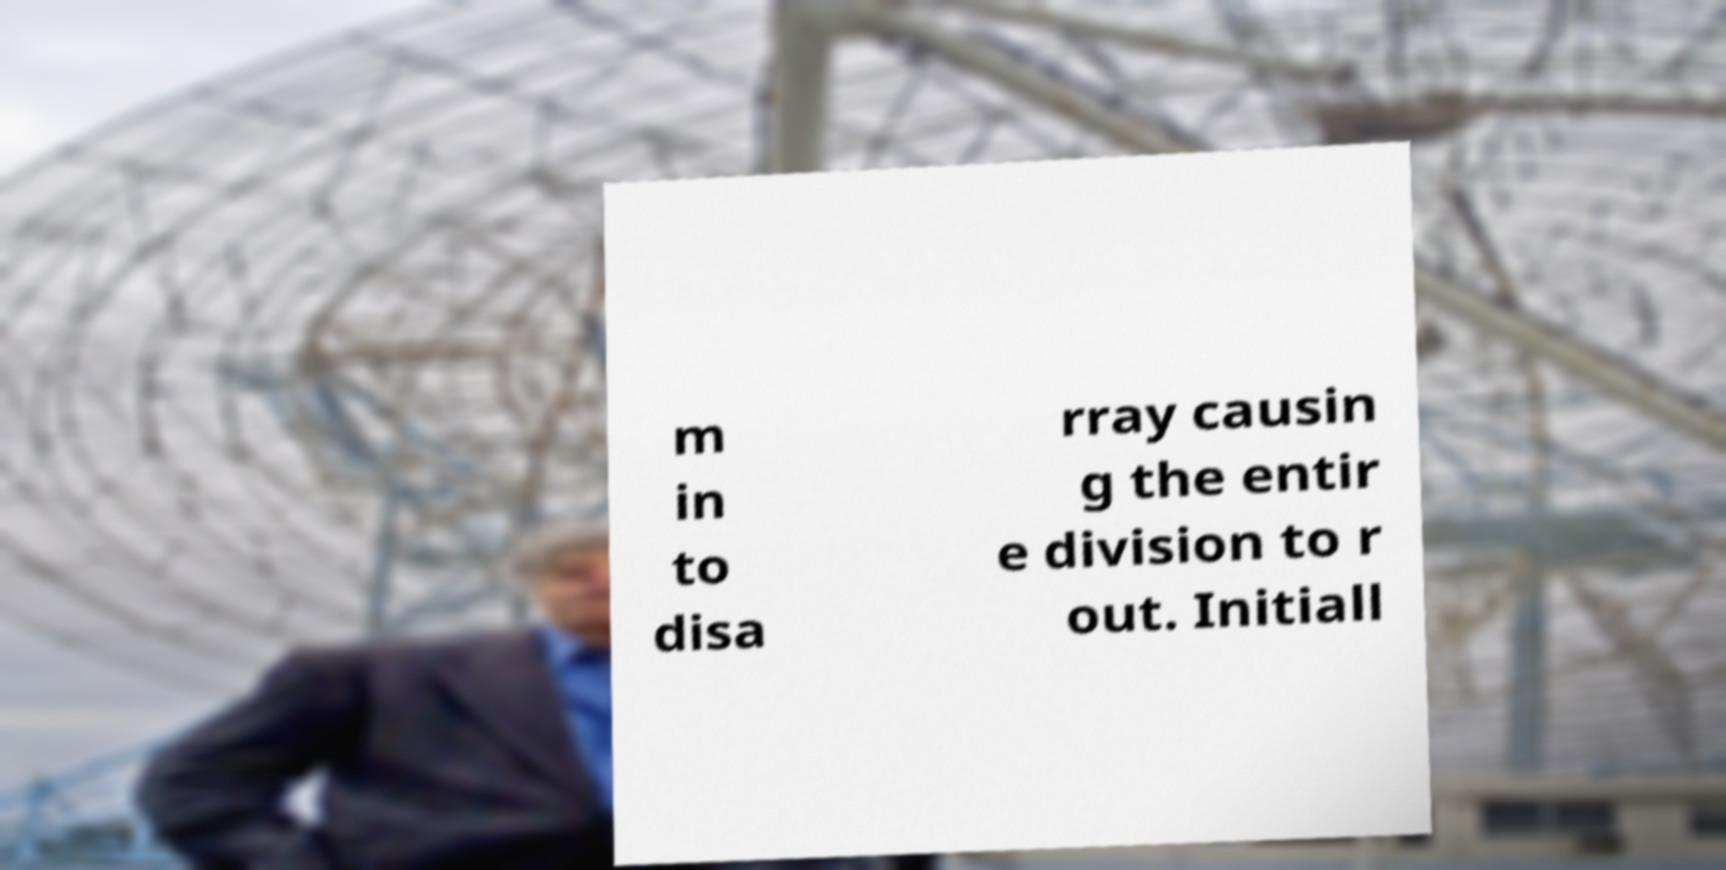Could you extract and type out the text from this image? m in to disa rray causin g the entir e division to r out. Initiall 